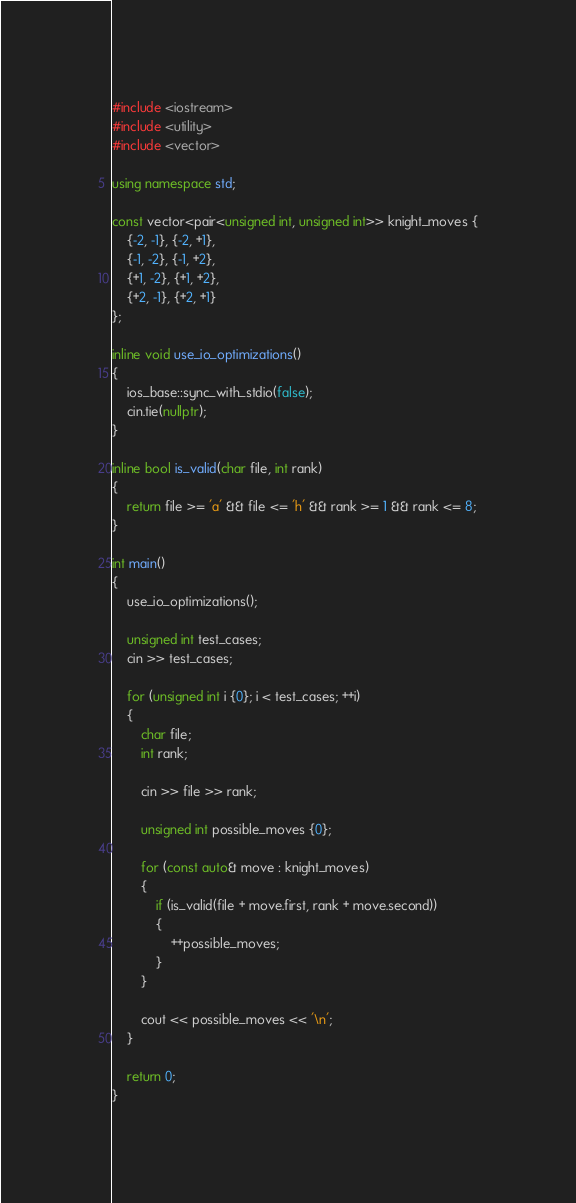Convert code to text. <code><loc_0><loc_0><loc_500><loc_500><_C++_>#include <iostream>
#include <utility>
#include <vector>

using namespace std;

const vector<pair<unsigned int, unsigned int>> knight_moves {
    {-2, -1}, {-2, +1},
    {-1, -2}, {-1, +2},
    {+1, -2}, {+1, +2},
    {+2, -1}, {+2, +1}
};

inline void use_io_optimizations()
{
    ios_base::sync_with_stdio(false);
    cin.tie(nullptr);
}

inline bool is_valid(char file, int rank)
{
    return file >= 'a' && file <= 'h' && rank >= 1 && rank <= 8;
}

int main()
{
    use_io_optimizations();

    unsigned int test_cases;
    cin >> test_cases;

    for (unsigned int i {0}; i < test_cases; ++i)
    {
        char file;
        int rank;

        cin >> file >> rank;

        unsigned int possible_moves {0};

        for (const auto& move : knight_moves)
        {
            if (is_valid(file + move.first, rank + move.second))
            {
                ++possible_moves;
            }
        }

        cout << possible_moves << '\n';
    }

    return 0;
}
</code> 